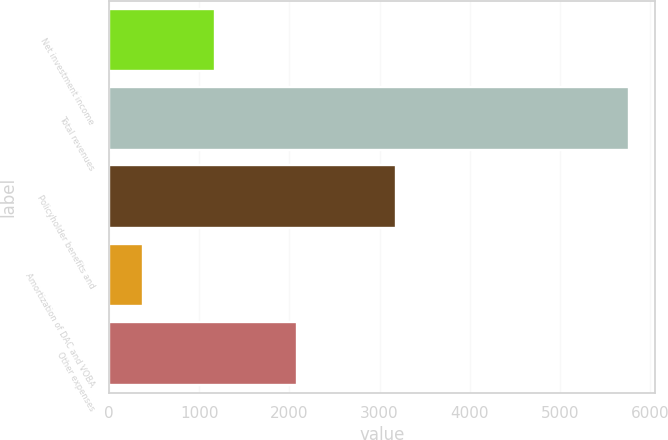Convert chart to OTSL. <chart><loc_0><loc_0><loc_500><loc_500><bar_chart><fcel>Net investment income<fcel>Total revenues<fcel>Policyholder benefits and<fcel>Amortization of DAC and VOBA<fcel>Other expenses<nl><fcel>1180<fcel>5763<fcel>3185<fcel>381<fcel>2079<nl></chart> 